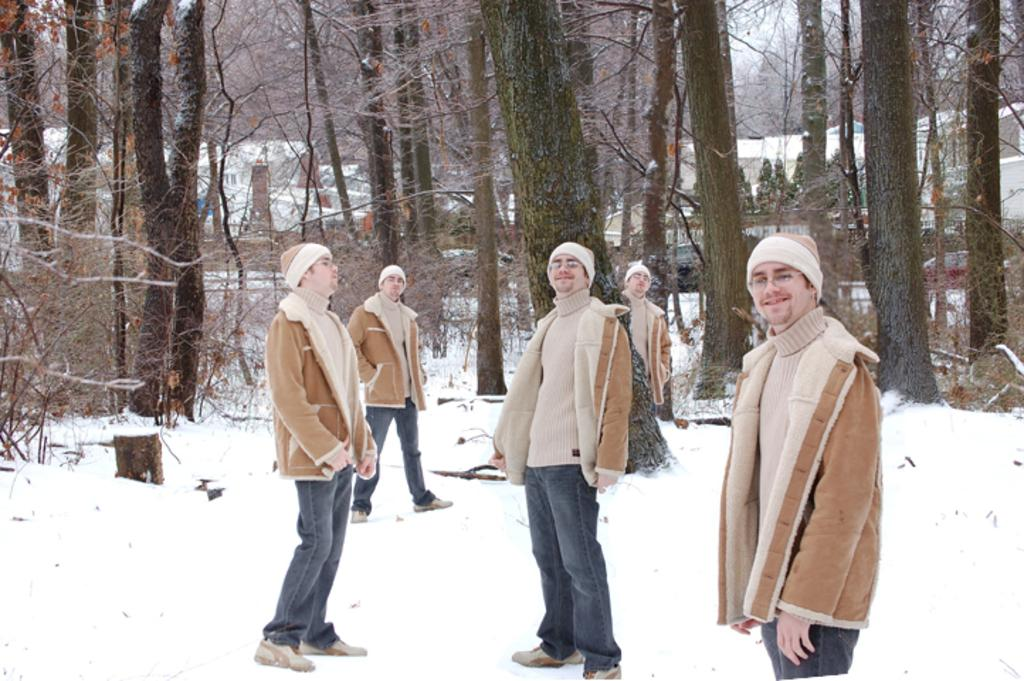Who or what is present in the image? There is a person in the image. What is the person standing on in the image? The person is on a snow surface. How many different angles of the person can be seen in the image? There are different angles of the person in the image. What can be seen in the background of the image? There are trees and houses in the background of the image. What is the rate at which the horse is galloping in the image? There is no horse present in the image, so it is not possible to determine the rate at which a horse might be galloping. 